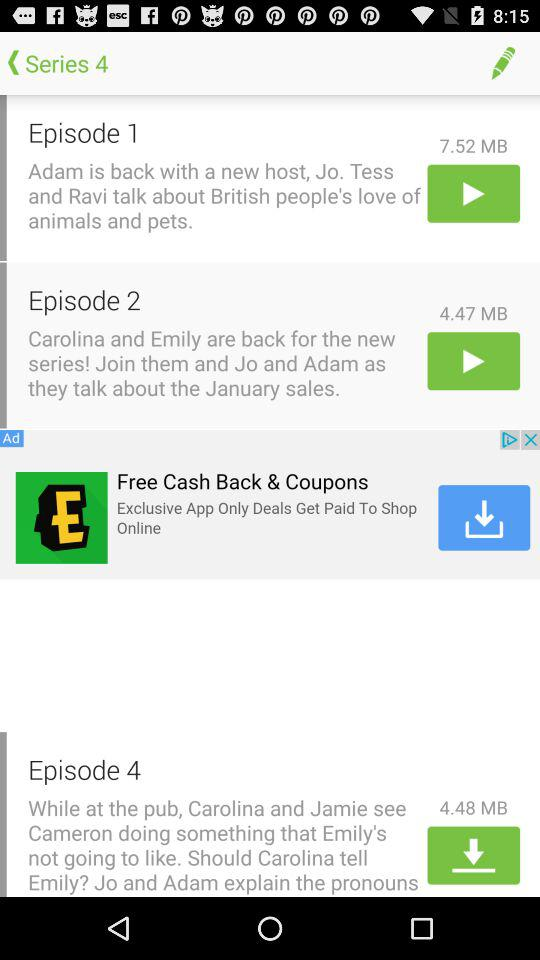What is the size of Episode 4 in megabytes? The size of Episode 4 is 4.48 megabytes. 